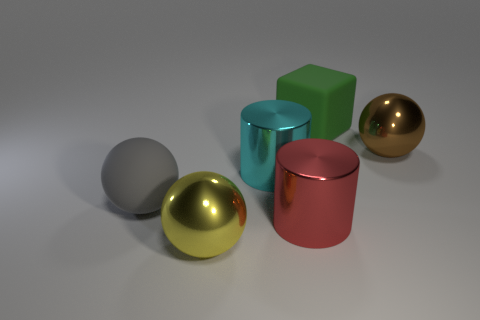Add 2 gray things. How many objects exist? 8 Subtract all cylinders. How many objects are left? 4 Subtract 0 brown blocks. How many objects are left? 6 Subtract all tiny brown things. Subtract all large metallic cylinders. How many objects are left? 4 Add 4 metallic cylinders. How many metallic cylinders are left? 6 Add 2 large cyan cylinders. How many large cyan cylinders exist? 3 